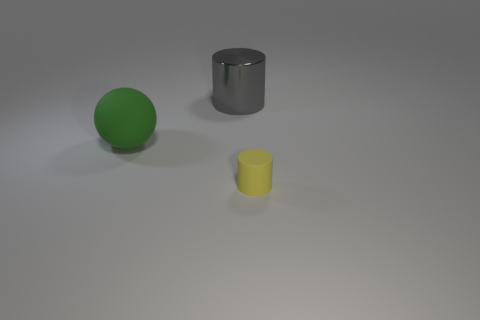Are the small cylinder and the thing left of the big gray metallic object made of the same material?
Provide a succinct answer. Yes. What is the material of the green object that is the same size as the gray cylinder?
Your answer should be very brief. Rubber. Are there any other green matte balls that have the same size as the green rubber ball?
Your answer should be very brief. No. What is the shape of the metal object that is the same size as the green ball?
Your response must be concise. Cylinder. There is a object that is both on the right side of the big rubber thing and in front of the gray cylinder; what shape is it?
Your answer should be very brief. Cylinder. Are there any green matte objects to the left of the rubber object that is on the left side of the cylinder behind the big green rubber sphere?
Offer a terse response. No. What number of other objects are there of the same material as the large gray cylinder?
Provide a short and direct response. 0. What number of big blue metallic balls are there?
Give a very brief answer. 0. How many objects are big brown metallic cubes or rubber things that are behind the yellow cylinder?
Provide a short and direct response. 1. Is there anything else that has the same shape as the big green rubber thing?
Your response must be concise. No. 